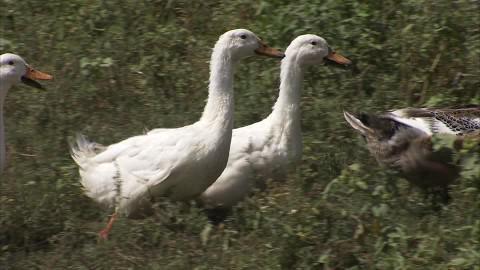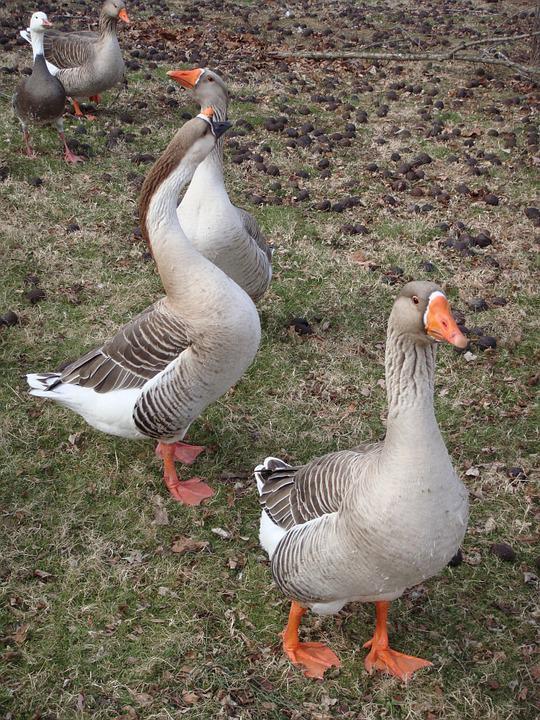The first image is the image on the left, the second image is the image on the right. For the images shown, is this caption "The right image does not depict more geese than the left image." true? Answer yes or no. No. 